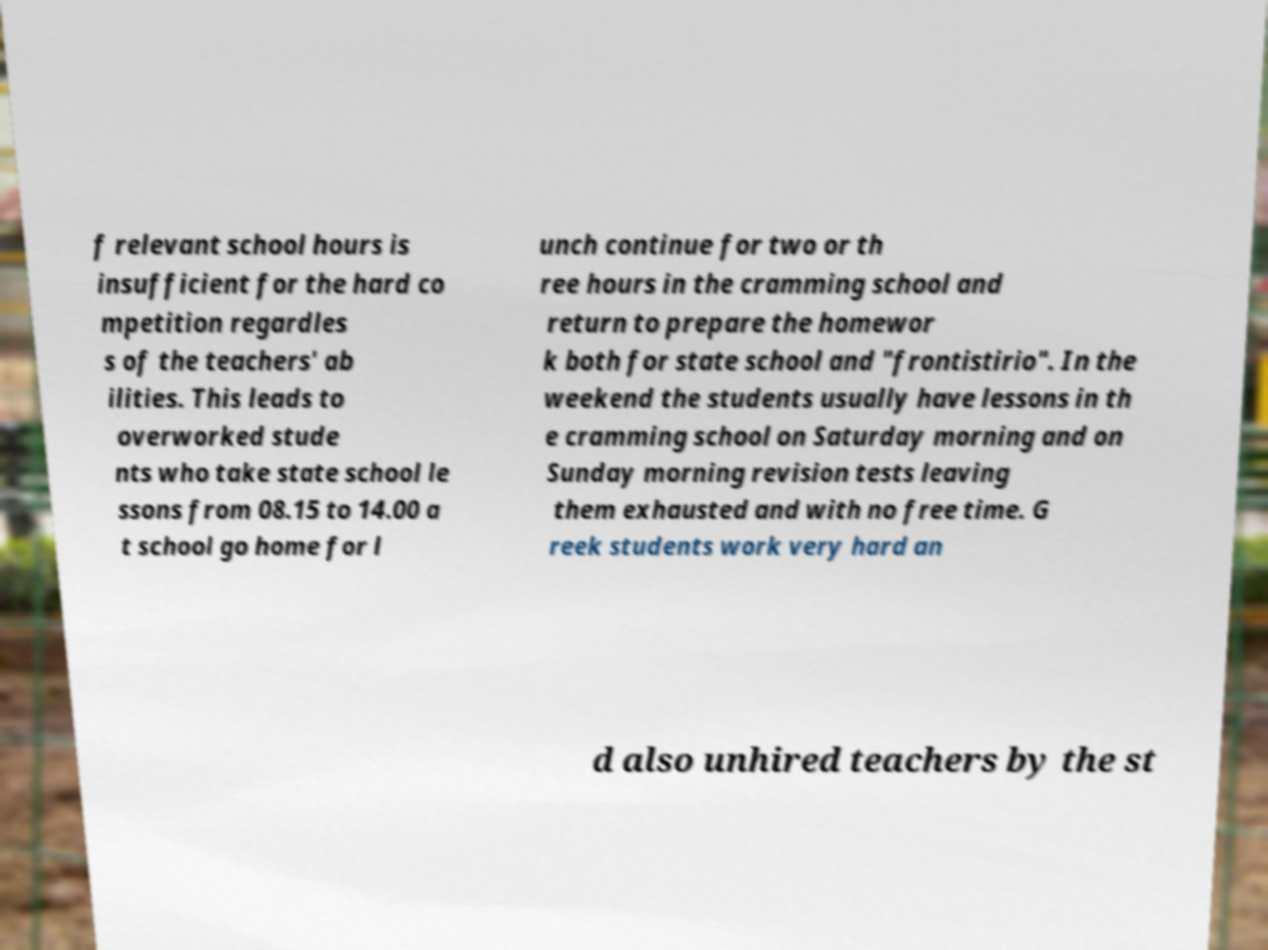Could you assist in decoding the text presented in this image and type it out clearly? f relevant school hours is insufficient for the hard co mpetition regardles s of the teachers' ab ilities. This leads to overworked stude nts who take state school le ssons from 08.15 to 14.00 a t school go home for l unch continue for two or th ree hours in the cramming school and return to prepare the homewor k both for state school and "frontistirio". In the weekend the students usually have lessons in th e cramming school on Saturday morning and on Sunday morning revision tests leaving them exhausted and with no free time. G reek students work very hard an d also unhired teachers by the st 